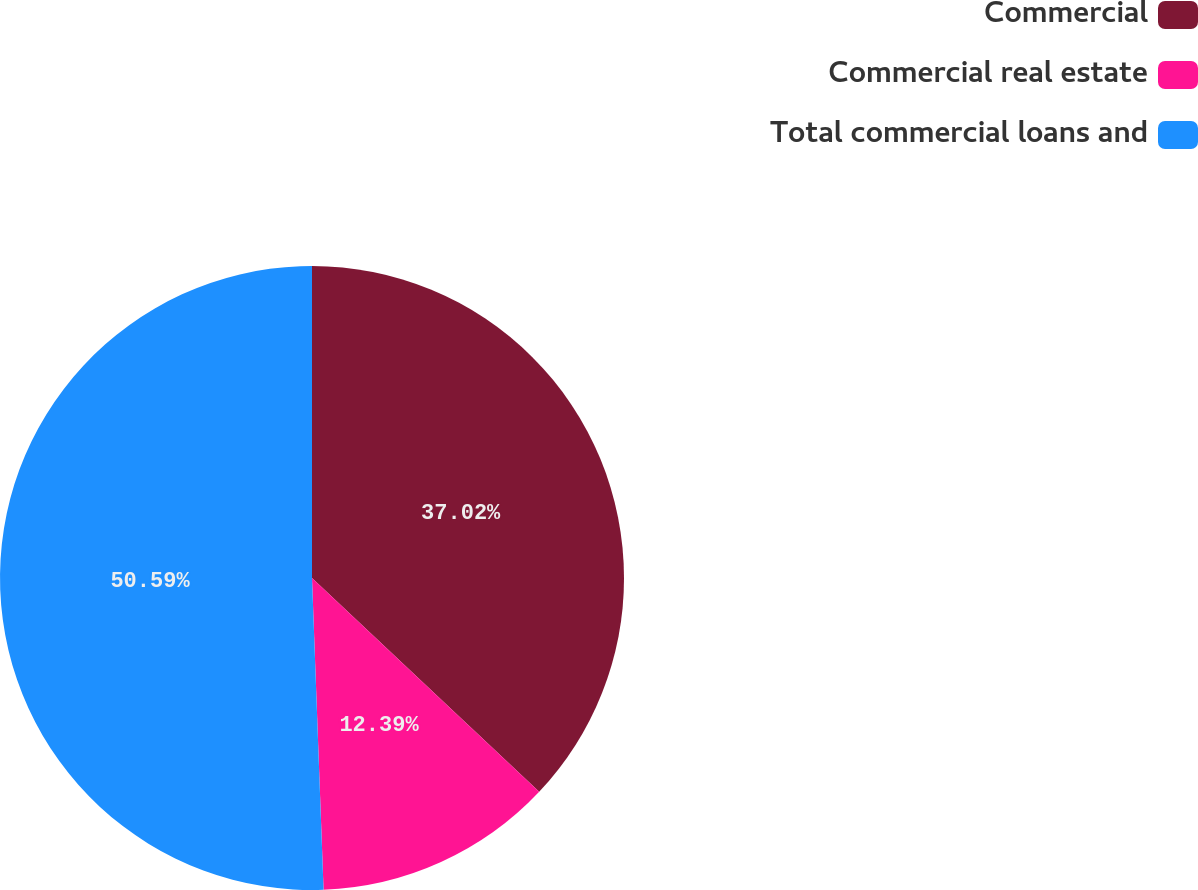Convert chart. <chart><loc_0><loc_0><loc_500><loc_500><pie_chart><fcel>Commercial<fcel>Commercial real estate<fcel>Total commercial loans and<nl><fcel>37.02%<fcel>12.39%<fcel>50.59%<nl></chart> 